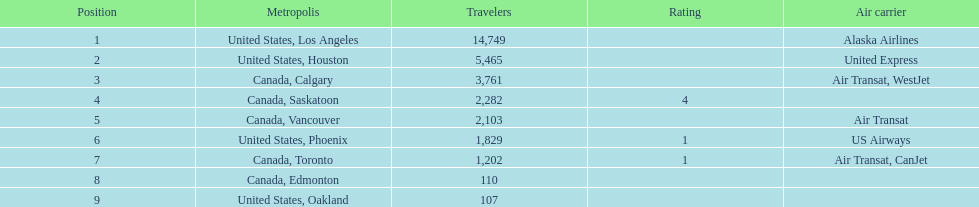What is the average number of passengers in the united states? 5537.5. 